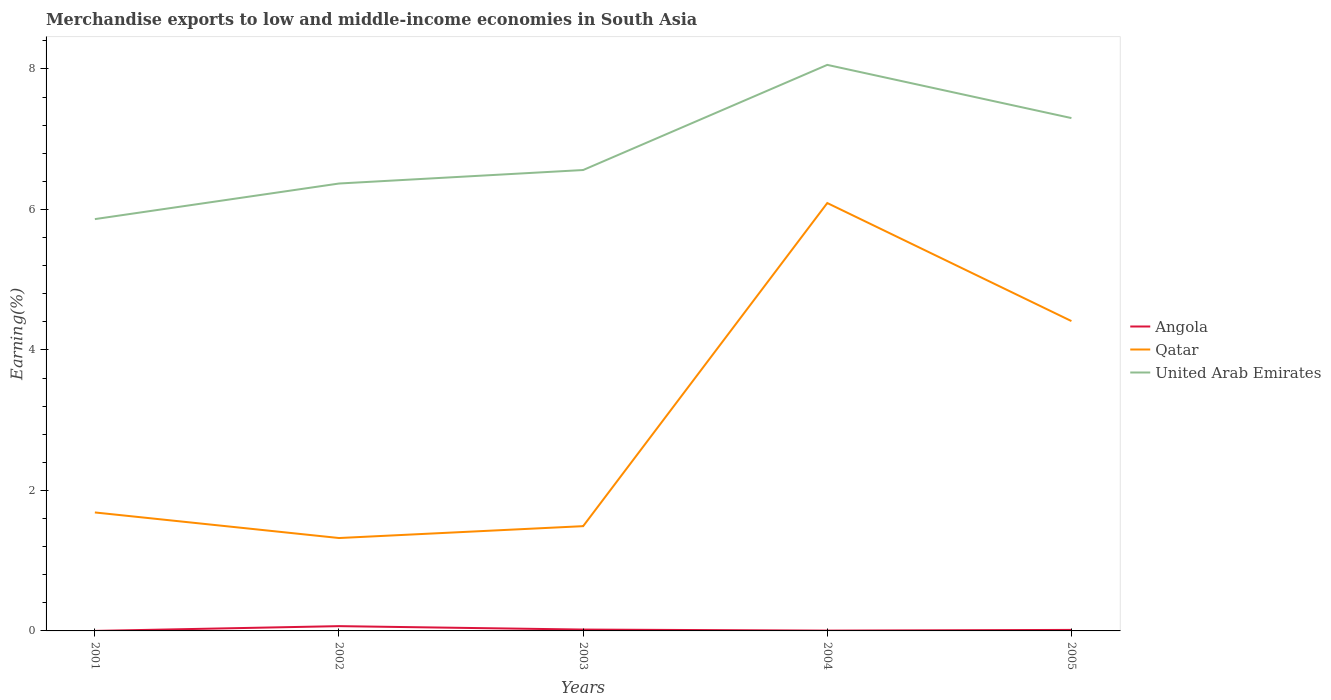How many different coloured lines are there?
Make the answer very short. 3. Does the line corresponding to Qatar intersect with the line corresponding to United Arab Emirates?
Your answer should be compact. No. Is the number of lines equal to the number of legend labels?
Give a very brief answer. Yes. Across all years, what is the maximum percentage of amount earned from merchandise exports in Qatar?
Ensure brevity in your answer.  1.32. What is the total percentage of amount earned from merchandise exports in Qatar in the graph?
Ensure brevity in your answer.  -2.72. What is the difference between the highest and the second highest percentage of amount earned from merchandise exports in Angola?
Ensure brevity in your answer.  0.07. Is the percentage of amount earned from merchandise exports in Angola strictly greater than the percentage of amount earned from merchandise exports in Qatar over the years?
Your response must be concise. Yes. How many lines are there?
Your response must be concise. 3. How many years are there in the graph?
Ensure brevity in your answer.  5. Does the graph contain any zero values?
Provide a short and direct response. No. What is the title of the graph?
Give a very brief answer. Merchandise exports to low and middle-income economies in South Asia. What is the label or title of the X-axis?
Offer a terse response. Years. What is the label or title of the Y-axis?
Keep it short and to the point. Earning(%). What is the Earning(%) of Angola in 2001?
Your answer should be compact. 0. What is the Earning(%) in Qatar in 2001?
Offer a very short reply. 1.69. What is the Earning(%) in United Arab Emirates in 2001?
Your answer should be compact. 5.86. What is the Earning(%) of Angola in 2002?
Your answer should be very brief. 0.07. What is the Earning(%) in Qatar in 2002?
Offer a very short reply. 1.32. What is the Earning(%) in United Arab Emirates in 2002?
Your answer should be compact. 6.37. What is the Earning(%) of Angola in 2003?
Offer a terse response. 0.02. What is the Earning(%) of Qatar in 2003?
Your response must be concise. 1.49. What is the Earning(%) in United Arab Emirates in 2003?
Ensure brevity in your answer.  6.56. What is the Earning(%) in Angola in 2004?
Your answer should be very brief. 0. What is the Earning(%) of Qatar in 2004?
Make the answer very short. 6.09. What is the Earning(%) of United Arab Emirates in 2004?
Your answer should be very brief. 8.06. What is the Earning(%) in Angola in 2005?
Your answer should be very brief. 0.01. What is the Earning(%) of Qatar in 2005?
Offer a terse response. 4.41. What is the Earning(%) of United Arab Emirates in 2005?
Provide a short and direct response. 7.3. Across all years, what is the maximum Earning(%) in Angola?
Offer a very short reply. 0.07. Across all years, what is the maximum Earning(%) of Qatar?
Offer a very short reply. 6.09. Across all years, what is the maximum Earning(%) in United Arab Emirates?
Your answer should be compact. 8.06. Across all years, what is the minimum Earning(%) of Angola?
Your answer should be very brief. 0. Across all years, what is the minimum Earning(%) of Qatar?
Give a very brief answer. 1.32. Across all years, what is the minimum Earning(%) in United Arab Emirates?
Give a very brief answer. 5.86. What is the total Earning(%) of Angola in the graph?
Ensure brevity in your answer.  0.11. What is the total Earning(%) of Qatar in the graph?
Your response must be concise. 15. What is the total Earning(%) of United Arab Emirates in the graph?
Provide a short and direct response. 34.15. What is the difference between the Earning(%) of Angola in 2001 and that in 2002?
Give a very brief answer. -0.07. What is the difference between the Earning(%) of Qatar in 2001 and that in 2002?
Your answer should be compact. 0.36. What is the difference between the Earning(%) in United Arab Emirates in 2001 and that in 2002?
Offer a very short reply. -0.51. What is the difference between the Earning(%) in Angola in 2001 and that in 2003?
Offer a very short reply. -0.02. What is the difference between the Earning(%) of Qatar in 2001 and that in 2003?
Provide a succinct answer. 0.2. What is the difference between the Earning(%) of United Arab Emirates in 2001 and that in 2003?
Your answer should be very brief. -0.7. What is the difference between the Earning(%) in Angola in 2001 and that in 2004?
Ensure brevity in your answer.  -0. What is the difference between the Earning(%) in Qatar in 2001 and that in 2004?
Provide a succinct answer. -4.4. What is the difference between the Earning(%) in United Arab Emirates in 2001 and that in 2004?
Provide a short and direct response. -2.2. What is the difference between the Earning(%) in Angola in 2001 and that in 2005?
Ensure brevity in your answer.  -0.01. What is the difference between the Earning(%) in Qatar in 2001 and that in 2005?
Make the answer very short. -2.72. What is the difference between the Earning(%) in United Arab Emirates in 2001 and that in 2005?
Offer a very short reply. -1.44. What is the difference between the Earning(%) in Angola in 2002 and that in 2003?
Your response must be concise. 0.05. What is the difference between the Earning(%) of Qatar in 2002 and that in 2003?
Make the answer very short. -0.17. What is the difference between the Earning(%) of United Arab Emirates in 2002 and that in 2003?
Keep it short and to the point. -0.19. What is the difference between the Earning(%) of Angola in 2002 and that in 2004?
Provide a succinct answer. 0.06. What is the difference between the Earning(%) of Qatar in 2002 and that in 2004?
Offer a terse response. -4.77. What is the difference between the Earning(%) in United Arab Emirates in 2002 and that in 2004?
Offer a very short reply. -1.69. What is the difference between the Earning(%) in Angola in 2002 and that in 2005?
Provide a short and direct response. 0.05. What is the difference between the Earning(%) in Qatar in 2002 and that in 2005?
Your answer should be compact. -3.09. What is the difference between the Earning(%) in United Arab Emirates in 2002 and that in 2005?
Give a very brief answer. -0.93. What is the difference between the Earning(%) in Angola in 2003 and that in 2004?
Make the answer very short. 0.01. What is the difference between the Earning(%) of Qatar in 2003 and that in 2004?
Provide a succinct answer. -4.6. What is the difference between the Earning(%) of United Arab Emirates in 2003 and that in 2004?
Keep it short and to the point. -1.5. What is the difference between the Earning(%) in Angola in 2003 and that in 2005?
Ensure brevity in your answer.  0. What is the difference between the Earning(%) of Qatar in 2003 and that in 2005?
Make the answer very short. -2.92. What is the difference between the Earning(%) of United Arab Emirates in 2003 and that in 2005?
Your response must be concise. -0.74. What is the difference between the Earning(%) in Angola in 2004 and that in 2005?
Your response must be concise. -0.01. What is the difference between the Earning(%) in Qatar in 2004 and that in 2005?
Ensure brevity in your answer.  1.68. What is the difference between the Earning(%) of United Arab Emirates in 2004 and that in 2005?
Your answer should be compact. 0.76. What is the difference between the Earning(%) in Angola in 2001 and the Earning(%) in Qatar in 2002?
Offer a very short reply. -1.32. What is the difference between the Earning(%) in Angola in 2001 and the Earning(%) in United Arab Emirates in 2002?
Offer a terse response. -6.37. What is the difference between the Earning(%) of Qatar in 2001 and the Earning(%) of United Arab Emirates in 2002?
Offer a very short reply. -4.68. What is the difference between the Earning(%) in Angola in 2001 and the Earning(%) in Qatar in 2003?
Keep it short and to the point. -1.49. What is the difference between the Earning(%) of Angola in 2001 and the Earning(%) of United Arab Emirates in 2003?
Make the answer very short. -6.56. What is the difference between the Earning(%) of Qatar in 2001 and the Earning(%) of United Arab Emirates in 2003?
Offer a very short reply. -4.88. What is the difference between the Earning(%) of Angola in 2001 and the Earning(%) of Qatar in 2004?
Offer a very short reply. -6.09. What is the difference between the Earning(%) of Angola in 2001 and the Earning(%) of United Arab Emirates in 2004?
Make the answer very short. -8.06. What is the difference between the Earning(%) in Qatar in 2001 and the Earning(%) in United Arab Emirates in 2004?
Your answer should be compact. -6.37. What is the difference between the Earning(%) in Angola in 2001 and the Earning(%) in Qatar in 2005?
Your response must be concise. -4.41. What is the difference between the Earning(%) in Angola in 2001 and the Earning(%) in United Arab Emirates in 2005?
Your response must be concise. -7.3. What is the difference between the Earning(%) in Qatar in 2001 and the Earning(%) in United Arab Emirates in 2005?
Make the answer very short. -5.61. What is the difference between the Earning(%) of Angola in 2002 and the Earning(%) of Qatar in 2003?
Provide a short and direct response. -1.42. What is the difference between the Earning(%) of Angola in 2002 and the Earning(%) of United Arab Emirates in 2003?
Your response must be concise. -6.49. What is the difference between the Earning(%) of Qatar in 2002 and the Earning(%) of United Arab Emirates in 2003?
Provide a short and direct response. -5.24. What is the difference between the Earning(%) in Angola in 2002 and the Earning(%) in Qatar in 2004?
Your answer should be compact. -6.02. What is the difference between the Earning(%) in Angola in 2002 and the Earning(%) in United Arab Emirates in 2004?
Ensure brevity in your answer.  -7.99. What is the difference between the Earning(%) in Qatar in 2002 and the Earning(%) in United Arab Emirates in 2004?
Offer a terse response. -6.74. What is the difference between the Earning(%) of Angola in 2002 and the Earning(%) of Qatar in 2005?
Your answer should be compact. -4.34. What is the difference between the Earning(%) in Angola in 2002 and the Earning(%) in United Arab Emirates in 2005?
Ensure brevity in your answer.  -7.23. What is the difference between the Earning(%) of Qatar in 2002 and the Earning(%) of United Arab Emirates in 2005?
Provide a succinct answer. -5.98. What is the difference between the Earning(%) in Angola in 2003 and the Earning(%) in Qatar in 2004?
Give a very brief answer. -6.07. What is the difference between the Earning(%) of Angola in 2003 and the Earning(%) of United Arab Emirates in 2004?
Make the answer very short. -8.04. What is the difference between the Earning(%) in Qatar in 2003 and the Earning(%) in United Arab Emirates in 2004?
Your response must be concise. -6.57. What is the difference between the Earning(%) in Angola in 2003 and the Earning(%) in Qatar in 2005?
Your answer should be very brief. -4.39. What is the difference between the Earning(%) of Angola in 2003 and the Earning(%) of United Arab Emirates in 2005?
Provide a short and direct response. -7.28. What is the difference between the Earning(%) of Qatar in 2003 and the Earning(%) of United Arab Emirates in 2005?
Offer a terse response. -5.81. What is the difference between the Earning(%) of Angola in 2004 and the Earning(%) of Qatar in 2005?
Offer a terse response. -4.41. What is the difference between the Earning(%) in Angola in 2004 and the Earning(%) in United Arab Emirates in 2005?
Ensure brevity in your answer.  -7.3. What is the difference between the Earning(%) of Qatar in 2004 and the Earning(%) of United Arab Emirates in 2005?
Make the answer very short. -1.21. What is the average Earning(%) of Angola per year?
Ensure brevity in your answer.  0.02. What is the average Earning(%) in Qatar per year?
Give a very brief answer. 3. What is the average Earning(%) of United Arab Emirates per year?
Provide a succinct answer. 6.83. In the year 2001, what is the difference between the Earning(%) of Angola and Earning(%) of Qatar?
Your answer should be compact. -1.69. In the year 2001, what is the difference between the Earning(%) in Angola and Earning(%) in United Arab Emirates?
Provide a short and direct response. -5.86. In the year 2001, what is the difference between the Earning(%) of Qatar and Earning(%) of United Arab Emirates?
Make the answer very short. -4.18. In the year 2002, what is the difference between the Earning(%) in Angola and Earning(%) in Qatar?
Ensure brevity in your answer.  -1.25. In the year 2002, what is the difference between the Earning(%) of Angola and Earning(%) of United Arab Emirates?
Provide a short and direct response. -6.3. In the year 2002, what is the difference between the Earning(%) in Qatar and Earning(%) in United Arab Emirates?
Give a very brief answer. -5.05. In the year 2003, what is the difference between the Earning(%) in Angola and Earning(%) in Qatar?
Your answer should be very brief. -1.47. In the year 2003, what is the difference between the Earning(%) in Angola and Earning(%) in United Arab Emirates?
Your answer should be very brief. -6.54. In the year 2003, what is the difference between the Earning(%) in Qatar and Earning(%) in United Arab Emirates?
Make the answer very short. -5.07. In the year 2004, what is the difference between the Earning(%) of Angola and Earning(%) of Qatar?
Provide a succinct answer. -6.09. In the year 2004, what is the difference between the Earning(%) of Angola and Earning(%) of United Arab Emirates?
Provide a short and direct response. -8.05. In the year 2004, what is the difference between the Earning(%) in Qatar and Earning(%) in United Arab Emirates?
Your answer should be very brief. -1.97. In the year 2005, what is the difference between the Earning(%) in Angola and Earning(%) in Qatar?
Your response must be concise. -4.4. In the year 2005, what is the difference between the Earning(%) in Angola and Earning(%) in United Arab Emirates?
Give a very brief answer. -7.29. In the year 2005, what is the difference between the Earning(%) in Qatar and Earning(%) in United Arab Emirates?
Offer a very short reply. -2.89. What is the ratio of the Earning(%) in Angola in 2001 to that in 2002?
Give a very brief answer. 0. What is the ratio of the Earning(%) in Qatar in 2001 to that in 2002?
Keep it short and to the point. 1.28. What is the ratio of the Earning(%) of United Arab Emirates in 2001 to that in 2002?
Your answer should be compact. 0.92. What is the ratio of the Earning(%) of Angola in 2001 to that in 2003?
Ensure brevity in your answer.  0.01. What is the ratio of the Earning(%) of Qatar in 2001 to that in 2003?
Your answer should be compact. 1.13. What is the ratio of the Earning(%) of United Arab Emirates in 2001 to that in 2003?
Your answer should be very brief. 0.89. What is the ratio of the Earning(%) in Angola in 2001 to that in 2004?
Your answer should be very brief. 0.04. What is the ratio of the Earning(%) in Qatar in 2001 to that in 2004?
Your answer should be very brief. 0.28. What is the ratio of the Earning(%) of United Arab Emirates in 2001 to that in 2004?
Offer a very short reply. 0.73. What is the ratio of the Earning(%) of Angola in 2001 to that in 2005?
Make the answer very short. 0.01. What is the ratio of the Earning(%) in Qatar in 2001 to that in 2005?
Your answer should be compact. 0.38. What is the ratio of the Earning(%) of United Arab Emirates in 2001 to that in 2005?
Ensure brevity in your answer.  0.8. What is the ratio of the Earning(%) of Angola in 2002 to that in 2003?
Offer a terse response. 3.53. What is the ratio of the Earning(%) in Qatar in 2002 to that in 2003?
Offer a very short reply. 0.89. What is the ratio of the Earning(%) in United Arab Emirates in 2002 to that in 2003?
Give a very brief answer. 0.97. What is the ratio of the Earning(%) of Angola in 2002 to that in 2004?
Make the answer very short. 15.25. What is the ratio of the Earning(%) of Qatar in 2002 to that in 2004?
Offer a terse response. 0.22. What is the ratio of the Earning(%) in United Arab Emirates in 2002 to that in 2004?
Provide a succinct answer. 0.79. What is the ratio of the Earning(%) of Angola in 2002 to that in 2005?
Your response must be concise. 4.68. What is the ratio of the Earning(%) in Qatar in 2002 to that in 2005?
Keep it short and to the point. 0.3. What is the ratio of the Earning(%) of United Arab Emirates in 2002 to that in 2005?
Ensure brevity in your answer.  0.87. What is the ratio of the Earning(%) in Angola in 2003 to that in 2004?
Keep it short and to the point. 4.32. What is the ratio of the Earning(%) of Qatar in 2003 to that in 2004?
Ensure brevity in your answer.  0.24. What is the ratio of the Earning(%) in United Arab Emirates in 2003 to that in 2004?
Give a very brief answer. 0.81. What is the ratio of the Earning(%) in Angola in 2003 to that in 2005?
Your response must be concise. 1.32. What is the ratio of the Earning(%) of Qatar in 2003 to that in 2005?
Your answer should be very brief. 0.34. What is the ratio of the Earning(%) in United Arab Emirates in 2003 to that in 2005?
Give a very brief answer. 0.9. What is the ratio of the Earning(%) of Angola in 2004 to that in 2005?
Ensure brevity in your answer.  0.31. What is the ratio of the Earning(%) in Qatar in 2004 to that in 2005?
Provide a succinct answer. 1.38. What is the ratio of the Earning(%) of United Arab Emirates in 2004 to that in 2005?
Your response must be concise. 1.1. What is the difference between the highest and the second highest Earning(%) in Angola?
Keep it short and to the point. 0.05. What is the difference between the highest and the second highest Earning(%) in Qatar?
Ensure brevity in your answer.  1.68. What is the difference between the highest and the second highest Earning(%) in United Arab Emirates?
Offer a terse response. 0.76. What is the difference between the highest and the lowest Earning(%) in Angola?
Offer a very short reply. 0.07. What is the difference between the highest and the lowest Earning(%) of Qatar?
Your response must be concise. 4.77. What is the difference between the highest and the lowest Earning(%) of United Arab Emirates?
Offer a terse response. 2.2. 